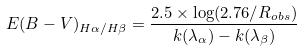Convert formula to latex. <formula><loc_0><loc_0><loc_500><loc_500>E ( B - V ) _ { H \alpha / H \beta } = \frac { 2 . 5 \times \log ( 2 . 7 6 / R _ { o b s } ) } { k ( \lambda _ { \alpha } ) - k ( \lambda _ { \beta } ) }</formula> 